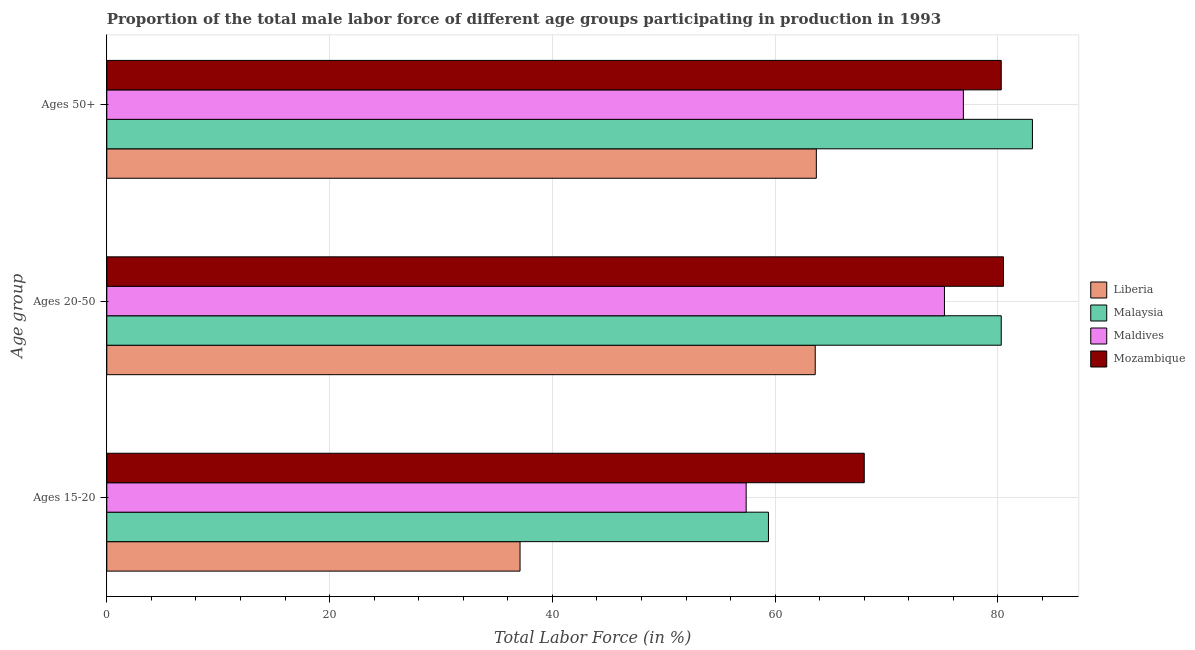How many different coloured bars are there?
Provide a succinct answer. 4. Are the number of bars per tick equal to the number of legend labels?
Your answer should be very brief. Yes. How many bars are there on the 2nd tick from the top?
Provide a short and direct response. 4. How many bars are there on the 3rd tick from the bottom?
Offer a terse response. 4. What is the label of the 2nd group of bars from the top?
Your answer should be very brief. Ages 20-50. What is the percentage of male labor force within the age group 15-20 in Mozambique?
Provide a succinct answer. 68. Across all countries, what is the maximum percentage of male labor force above age 50?
Ensure brevity in your answer.  83.1. Across all countries, what is the minimum percentage of male labor force above age 50?
Make the answer very short. 63.7. In which country was the percentage of male labor force above age 50 maximum?
Make the answer very short. Malaysia. In which country was the percentage of male labor force within the age group 15-20 minimum?
Keep it short and to the point. Liberia. What is the total percentage of male labor force within the age group 15-20 in the graph?
Make the answer very short. 221.9. What is the difference between the percentage of male labor force above age 50 in Maldives and that in Liberia?
Provide a short and direct response. 13.2. What is the difference between the percentage of male labor force within the age group 15-20 in Maldives and the percentage of male labor force above age 50 in Mozambique?
Give a very brief answer. -22.9. What is the average percentage of male labor force within the age group 15-20 per country?
Give a very brief answer. 55.48. What is the difference between the percentage of male labor force above age 50 and percentage of male labor force within the age group 15-20 in Malaysia?
Your answer should be compact. 23.7. In how many countries, is the percentage of male labor force within the age group 20-50 greater than 20 %?
Your response must be concise. 4. What is the ratio of the percentage of male labor force within the age group 15-20 in Maldives to that in Malaysia?
Offer a terse response. 0.97. What is the difference between the highest and the second highest percentage of male labor force within the age group 15-20?
Offer a terse response. 8.6. What is the difference between the highest and the lowest percentage of male labor force within the age group 15-20?
Offer a terse response. 30.9. Is the sum of the percentage of male labor force within the age group 15-20 in Mozambique and Maldives greater than the maximum percentage of male labor force within the age group 20-50 across all countries?
Give a very brief answer. Yes. What does the 1st bar from the top in Ages 50+ represents?
Offer a very short reply. Mozambique. What does the 1st bar from the bottom in Ages 15-20 represents?
Provide a short and direct response. Liberia. Is it the case that in every country, the sum of the percentage of male labor force within the age group 15-20 and percentage of male labor force within the age group 20-50 is greater than the percentage of male labor force above age 50?
Your response must be concise. Yes. Are all the bars in the graph horizontal?
Offer a very short reply. Yes. Are the values on the major ticks of X-axis written in scientific E-notation?
Offer a very short reply. No. Does the graph contain grids?
Keep it short and to the point. Yes. Where does the legend appear in the graph?
Give a very brief answer. Center right. How many legend labels are there?
Offer a very short reply. 4. What is the title of the graph?
Give a very brief answer. Proportion of the total male labor force of different age groups participating in production in 1993. What is the label or title of the X-axis?
Keep it short and to the point. Total Labor Force (in %). What is the label or title of the Y-axis?
Offer a terse response. Age group. What is the Total Labor Force (in %) of Liberia in Ages 15-20?
Give a very brief answer. 37.1. What is the Total Labor Force (in %) of Malaysia in Ages 15-20?
Offer a terse response. 59.4. What is the Total Labor Force (in %) of Maldives in Ages 15-20?
Give a very brief answer. 57.4. What is the Total Labor Force (in %) of Liberia in Ages 20-50?
Ensure brevity in your answer.  63.6. What is the Total Labor Force (in %) of Malaysia in Ages 20-50?
Make the answer very short. 80.3. What is the Total Labor Force (in %) in Maldives in Ages 20-50?
Make the answer very short. 75.2. What is the Total Labor Force (in %) of Mozambique in Ages 20-50?
Provide a succinct answer. 80.5. What is the Total Labor Force (in %) of Liberia in Ages 50+?
Your response must be concise. 63.7. What is the Total Labor Force (in %) of Malaysia in Ages 50+?
Make the answer very short. 83.1. What is the Total Labor Force (in %) in Maldives in Ages 50+?
Keep it short and to the point. 76.9. What is the Total Labor Force (in %) of Mozambique in Ages 50+?
Give a very brief answer. 80.3. Across all Age group, what is the maximum Total Labor Force (in %) of Liberia?
Provide a short and direct response. 63.7. Across all Age group, what is the maximum Total Labor Force (in %) in Malaysia?
Keep it short and to the point. 83.1. Across all Age group, what is the maximum Total Labor Force (in %) in Maldives?
Your response must be concise. 76.9. Across all Age group, what is the maximum Total Labor Force (in %) in Mozambique?
Offer a very short reply. 80.5. Across all Age group, what is the minimum Total Labor Force (in %) of Liberia?
Provide a succinct answer. 37.1. Across all Age group, what is the minimum Total Labor Force (in %) of Malaysia?
Provide a short and direct response. 59.4. Across all Age group, what is the minimum Total Labor Force (in %) of Maldives?
Make the answer very short. 57.4. What is the total Total Labor Force (in %) of Liberia in the graph?
Ensure brevity in your answer.  164.4. What is the total Total Labor Force (in %) of Malaysia in the graph?
Offer a terse response. 222.8. What is the total Total Labor Force (in %) of Maldives in the graph?
Make the answer very short. 209.5. What is the total Total Labor Force (in %) in Mozambique in the graph?
Give a very brief answer. 228.8. What is the difference between the Total Labor Force (in %) in Liberia in Ages 15-20 and that in Ages 20-50?
Your response must be concise. -26.5. What is the difference between the Total Labor Force (in %) in Malaysia in Ages 15-20 and that in Ages 20-50?
Offer a very short reply. -20.9. What is the difference between the Total Labor Force (in %) of Maldives in Ages 15-20 and that in Ages 20-50?
Your response must be concise. -17.8. What is the difference between the Total Labor Force (in %) of Liberia in Ages 15-20 and that in Ages 50+?
Offer a very short reply. -26.6. What is the difference between the Total Labor Force (in %) in Malaysia in Ages 15-20 and that in Ages 50+?
Your response must be concise. -23.7. What is the difference between the Total Labor Force (in %) in Maldives in Ages 15-20 and that in Ages 50+?
Ensure brevity in your answer.  -19.5. What is the difference between the Total Labor Force (in %) of Liberia in Ages 20-50 and that in Ages 50+?
Offer a very short reply. -0.1. What is the difference between the Total Labor Force (in %) of Malaysia in Ages 20-50 and that in Ages 50+?
Your answer should be very brief. -2.8. What is the difference between the Total Labor Force (in %) in Mozambique in Ages 20-50 and that in Ages 50+?
Give a very brief answer. 0.2. What is the difference between the Total Labor Force (in %) of Liberia in Ages 15-20 and the Total Labor Force (in %) of Malaysia in Ages 20-50?
Keep it short and to the point. -43.2. What is the difference between the Total Labor Force (in %) of Liberia in Ages 15-20 and the Total Labor Force (in %) of Maldives in Ages 20-50?
Offer a terse response. -38.1. What is the difference between the Total Labor Force (in %) in Liberia in Ages 15-20 and the Total Labor Force (in %) in Mozambique in Ages 20-50?
Keep it short and to the point. -43.4. What is the difference between the Total Labor Force (in %) of Malaysia in Ages 15-20 and the Total Labor Force (in %) of Maldives in Ages 20-50?
Keep it short and to the point. -15.8. What is the difference between the Total Labor Force (in %) of Malaysia in Ages 15-20 and the Total Labor Force (in %) of Mozambique in Ages 20-50?
Offer a terse response. -21.1. What is the difference between the Total Labor Force (in %) of Maldives in Ages 15-20 and the Total Labor Force (in %) of Mozambique in Ages 20-50?
Give a very brief answer. -23.1. What is the difference between the Total Labor Force (in %) of Liberia in Ages 15-20 and the Total Labor Force (in %) of Malaysia in Ages 50+?
Keep it short and to the point. -46. What is the difference between the Total Labor Force (in %) of Liberia in Ages 15-20 and the Total Labor Force (in %) of Maldives in Ages 50+?
Provide a succinct answer. -39.8. What is the difference between the Total Labor Force (in %) in Liberia in Ages 15-20 and the Total Labor Force (in %) in Mozambique in Ages 50+?
Keep it short and to the point. -43.2. What is the difference between the Total Labor Force (in %) in Malaysia in Ages 15-20 and the Total Labor Force (in %) in Maldives in Ages 50+?
Your answer should be very brief. -17.5. What is the difference between the Total Labor Force (in %) in Malaysia in Ages 15-20 and the Total Labor Force (in %) in Mozambique in Ages 50+?
Give a very brief answer. -20.9. What is the difference between the Total Labor Force (in %) of Maldives in Ages 15-20 and the Total Labor Force (in %) of Mozambique in Ages 50+?
Your response must be concise. -22.9. What is the difference between the Total Labor Force (in %) of Liberia in Ages 20-50 and the Total Labor Force (in %) of Malaysia in Ages 50+?
Ensure brevity in your answer.  -19.5. What is the difference between the Total Labor Force (in %) of Liberia in Ages 20-50 and the Total Labor Force (in %) of Mozambique in Ages 50+?
Provide a short and direct response. -16.7. What is the difference between the Total Labor Force (in %) in Malaysia in Ages 20-50 and the Total Labor Force (in %) in Maldives in Ages 50+?
Provide a short and direct response. 3.4. What is the difference between the Total Labor Force (in %) in Maldives in Ages 20-50 and the Total Labor Force (in %) in Mozambique in Ages 50+?
Offer a terse response. -5.1. What is the average Total Labor Force (in %) of Liberia per Age group?
Your answer should be very brief. 54.8. What is the average Total Labor Force (in %) in Malaysia per Age group?
Make the answer very short. 74.27. What is the average Total Labor Force (in %) in Maldives per Age group?
Make the answer very short. 69.83. What is the average Total Labor Force (in %) of Mozambique per Age group?
Give a very brief answer. 76.27. What is the difference between the Total Labor Force (in %) of Liberia and Total Labor Force (in %) of Malaysia in Ages 15-20?
Make the answer very short. -22.3. What is the difference between the Total Labor Force (in %) of Liberia and Total Labor Force (in %) of Maldives in Ages 15-20?
Provide a succinct answer. -20.3. What is the difference between the Total Labor Force (in %) of Liberia and Total Labor Force (in %) of Mozambique in Ages 15-20?
Give a very brief answer. -30.9. What is the difference between the Total Labor Force (in %) in Malaysia and Total Labor Force (in %) in Maldives in Ages 15-20?
Offer a terse response. 2. What is the difference between the Total Labor Force (in %) of Malaysia and Total Labor Force (in %) of Mozambique in Ages 15-20?
Give a very brief answer. -8.6. What is the difference between the Total Labor Force (in %) of Liberia and Total Labor Force (in %) of Malaysia in Ages 20-50?
Your answer should be very brief. -16.7. What is the difference between the Total Labor Force (in %) of Liberia and Total Labor Force (in %) of Maldives in Ages 20-50?
Provide a short and direct response. -11.6. What is the difference between the Total Labor Force (in %) in Liberia and Total Labor Force (in %) in Mozambique in Ages 20-50?
Provide a short and direct response. -16.9. What is the difference between the Total Labor Force (in %) in Liberia and Total Labor Force (in %) in Malaysia in Ages 50+?
Ensure brevity in your answer.  -19.4. What is the difference between the Total Labor Force (in %) of Liberia and Total Labor Force (in %) of Maldives in Ages 50+?
Ensure brevity in your answer.  -13.2. What is the difference between the Total Labor Force (in %) in Liberia and Total Labor Force (in %) in Mozambique in Ages 50+?
Offer a terse response. -16.6. What is the ratio of the Total Labor Force (in %) in Liberia in Ages 15-20 to that in Ages 20-50?
Your answer should be compact. 0.58. What is the ratio of the Total Labor Force (in %) in Malaysia in Ages 15-20 to that in Ages 20-50?
Offer a terse response. 0.74. What is the ratio of the Total Labor Force (in %) of Maldives in Ages 15-20 to that in Ages 20-50?
Provide a succinct answer. 0.76. What is the ratio of the Total Labor Force (in %) in Mozambique in Ages 15-20 to that in Ages 20-50?
Offer a very short reply. 0.84. What is the ratio of the Total Labor Force (in %) in Liberia in Ages 15-20 to that in Ages 50+?
Provide a short and direct response. 0.58. What is the ratio of the Total Labor Force (in %) of Malaysia in Ages 15-20 to that in Ages 50+?
Offer a very short reply. 0.71. What is the ratio of the Total Labor Force (in %) of Maldives in Ages 15-20 to that in Ages 50+?
Keep it short and to the point. 0.75. What is the ratio of the Total Labor Force (in %) of Mozambique in Ages 15-20 to that in Ages 50+?
Offer a terse response. 0.85. What is the ratio of the Total Labor Force (in %) of Liberia in Ages 20-50 to that in Ages 50+?
Give a very brief answer. 1. What is the ratio of the Total Labor Force (in %) in Malaysia in Ages 20-50 to that in Ages 50+?
Offer a very short reply. 0.97. What is the ratio of the Total Labor Force (in %) of Maldives in Ages 20-50 to that in Ages 50+?
Provide a succinct answer. 0.98. What is the difference between the highest and the second highest Total Labor Force (in %) of Liberia?
Give a very brief answer. 0.1. What is the difference between the highest and the second highest Total Labor Force (in %) in Mozambique?
Keep it short and to the point. 0.2. What is the difference between the highest and the lowest Total Labor Force (in %) of Liberia?
Ensure brevity in your answer.  26.6. What is the difference between the highest and the lowest Total Labor Force (in %) in Malaysia?
Your answer should be very brief. 23.7. What is the difference between the highest and the lowest Total Labor Force (in %) of Maldives?
Your answer should be very brief. 19.5. 